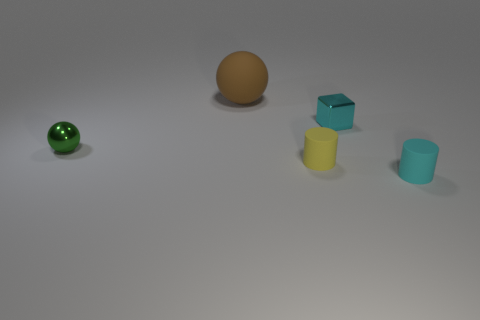There is a big brown object that is the same shape as the tiny green metal thing; what is it made of?
Your response must be concise. Rubber. How many other objects are there of the same shape as the cyan metal object?
Your answer should be compact. 0. How many small cyan metal cubes are in front of the tiny cylinder that is on the left side of the cylinder that is right of the shiny cube?
Keep it short and to the point. 0. What number of green objects are the same shape as the large brown object?
Your answer should be compact. 1. There is a cylinder that is in front of the tiny yellow cylinder; is its color the same as the block?
Keep it short and to the point. Yes. What is the shape of the rubber thing on the left side of the small yellow matte thing on the left side of the cyan matte cylinder in front of the big thing?
Your answer should be compact. Sphere. There is a shiny sphere; is it the same size as the matte object that is in front of the tiny yellow object?
Offer a terse response. Yes. Are there any matte cylinders that have the same size as the rubber ball?
Your answer should be very brief. No. What number of other things are the same material as the small green object?
Provide a short and direct response. 1. The object that is to the left of the tiny cyan cube and behind the green ball is what color?
Make the answer very short. Brown. 